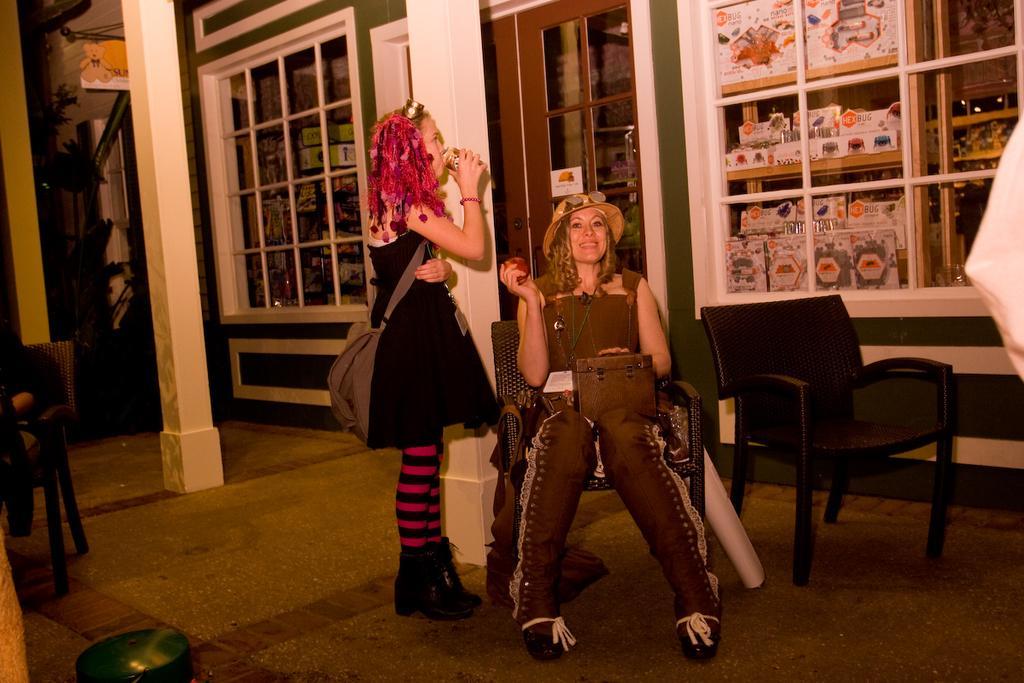Could you give a brief overview of what you see in this image? There are two females in this picture. One is standing and wearing a bag and holding a bottle in her hand. Another woman is sitting on a chair and holding an apple in her hand, wearing a hat. To the left of image there is a chair and a vessel. 